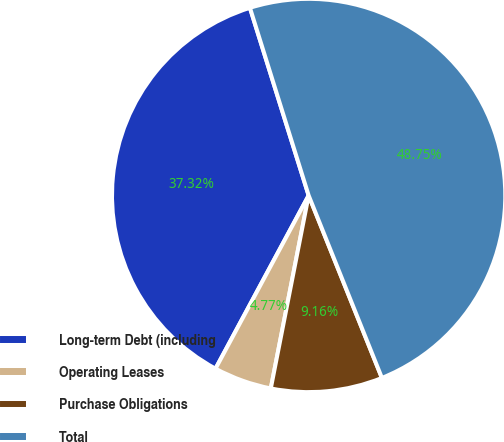Convert chart. <chart><loc_0><loc_0><loc_500><loc_500><pie_chart><fcel>Long-term Debt (including<fcel>Operating Leases<fcel>Purchase Obligations<fcel>Total<nl><fcel>37.32%<fcel>4.77%<fcel>9.16%<fcel>48.75%<nl></chart> 